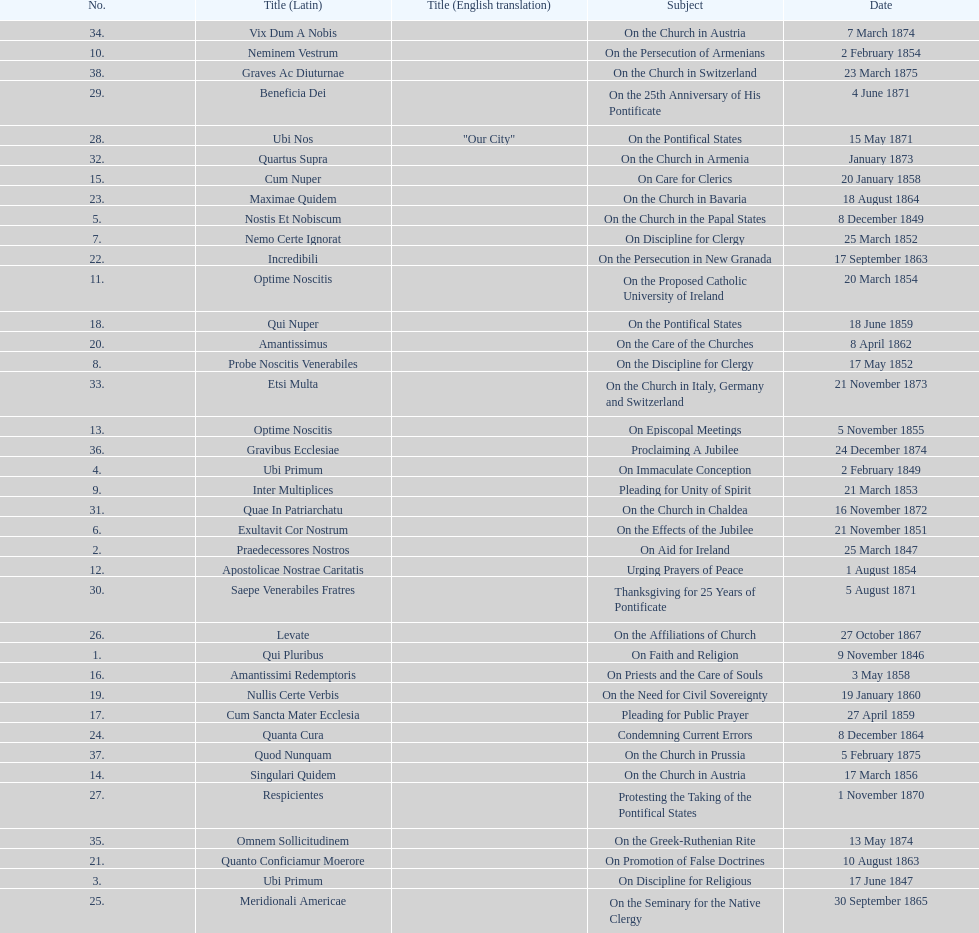How many areas of study are there? 38. 